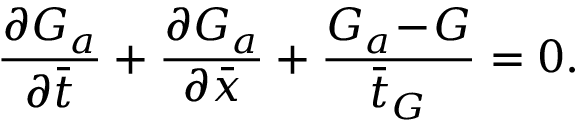Convert formula to latex. <formula><loc_0><loc_0><loc_500><loc_500>\frac { \partial G _ { a } } { \partial \bar { t } } + \frac { \partial G _ { a } } { \partial \bar { x } } + \frac { G _ { a } \, - \, G } { \bar { t } _ { G } } = 0 .</formula> 